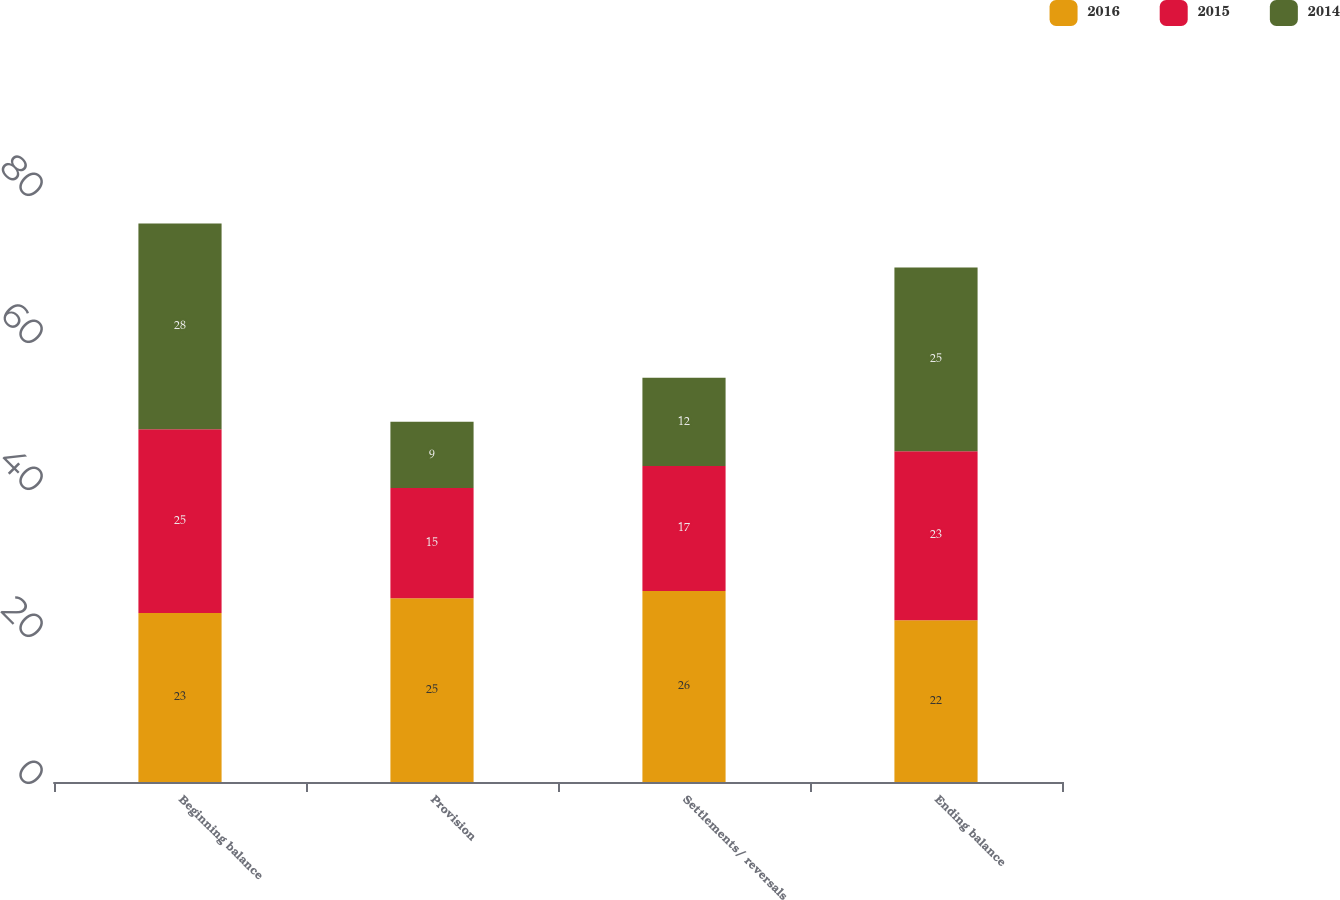<chart> <loc_0><loc_0><loc_500><loc_500><stacked_bar_chart><ecel><fcel>Beginning balance<fcel>Provision<fcel>Settlements/ reversals<fcel>Ending balance<nl><fcel>2016<fcel>23<fcel>25<fcel>26<fcel>22<nl><fcel>2015<fcel>25<fcel>15<fcel>17<fcel>23<nl><fcel>2014<fcel>28<fcel>9<fcel>12<fcel>25<nl></chart> 